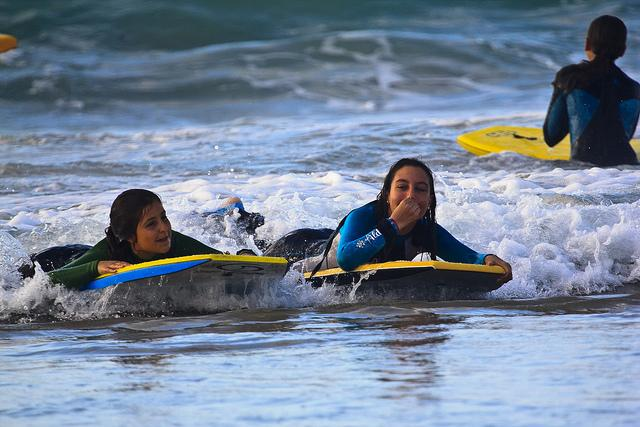Why are they lying down? Please explain your reasoning. to relax. They are enjoying themselves. 